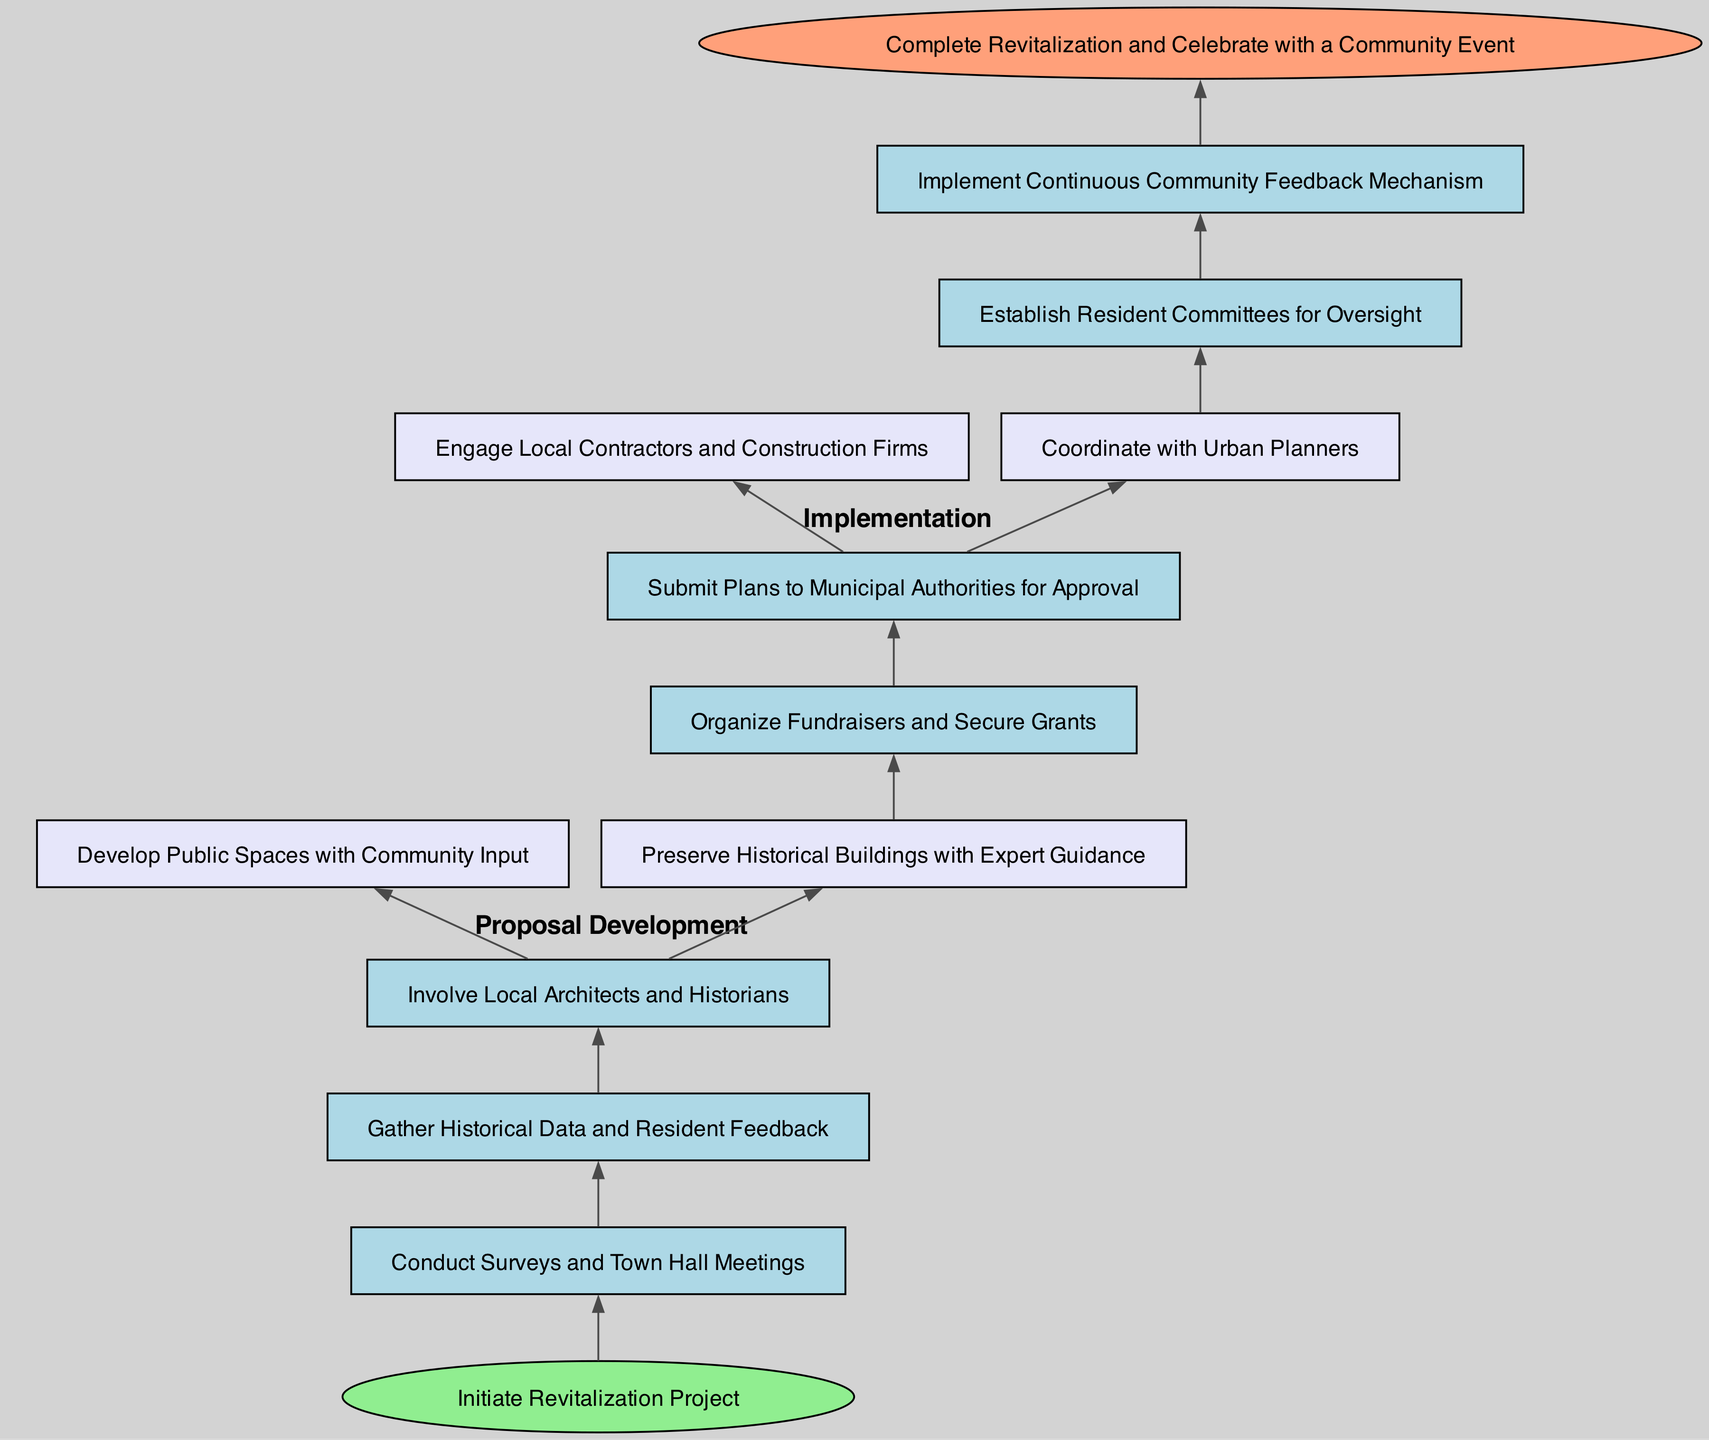What is the first step in the diagram? The diagram begins with the "Initiate Revitalization Project" node, which is the starting point of the flowchart.
Answer: Initiate Revitalization Project How many proposals are developed in the Proposal Development step? There are two proposals listed under the Proposal Development step: "Develop Public Spaces with Community Input" and "Preserve Historical Buildings with Expert Guidance".
Answer: 2 What type of committees are established during Community Monitoring? The Community Monitoring step establishes "Resident Committees for Oversight" to ensure that the community is actively involved in monitoring the progress of the revitalization.
Answer: Resident Committees for Oversight Which process follows Fundraising in the flowchart? After the Fundraising step, the next process is the Approval Process, where the plans are submitted to municipal authorities for approval.
Answer: Approval Process What are the two main activities involved in the Implementation step? The Implementation step includes two activities: "Engage Local Contractors and Construction Firms" and "Coordinate with Urban Planners".
Answer: Engage Local Contractors and Construction Firms, Coordinate with Urban Planners What feedback mechanism is implemented? The diagram specifies that a "Continuous Community Feedback Mechanism" is implemented to ensure that community members can share their thoughts and inputs throughout the revitalization process.
Answer: Continuous Community Feedback Mechanism What is the final event mentioned in the diagram? The flowchart concludes with "Complete Revitalization and Celebrate with a Community Event", indicating the joyful culmination of the project's efforts.
Answer: Complete Revitalization and Celebrate with a Community Event Which step involves input from the community? The "Conduct Surveys and Town Hall Meetings" step actively seeks input from the community to gather their opinions and ideas regarding the revitalization project.
Answer: Conduct Surveys and Town Hall Meetings How is the start of the process indicated in the flowchart? The start of the process is indicated by the "Start" node, which is an ellipse shape labeled "Initiate Revitalization Project" that serves as the entry point of the flowchart.
Answer: Start 